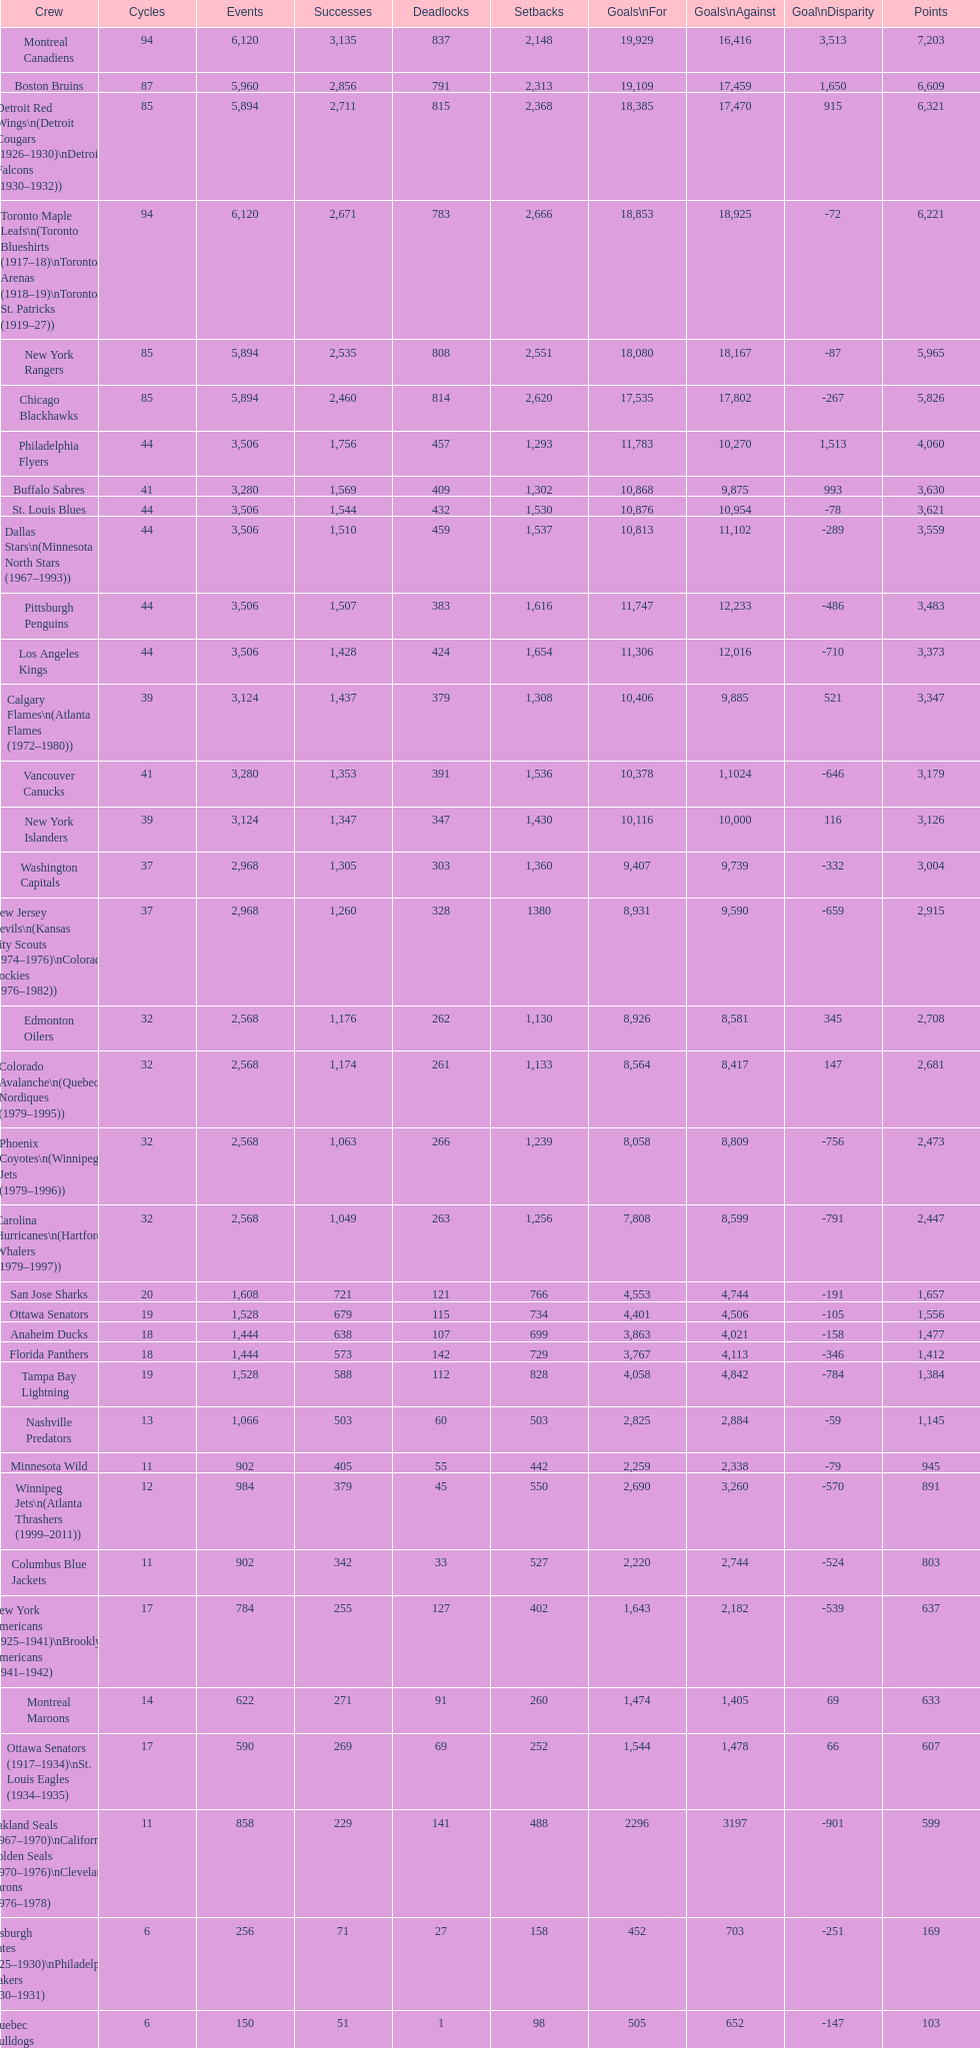Could you help me parse every detail presented in this table? {'header': ['Crew', 'Cycles', 'Events', 'Successes', 'Deadlocks', 'Setbacks', 'Goals\\nFor', 'Goals\\nAgainst', 'Goal\\nDisparity', 'Points'], 'rows': [['Montreal Canadiens', '94', '6,120', '3,135', '837', '2,148', '19,929', '16,416', '3,513', '7,203'], ['Boston Bruins', '87', '5,960', '2,856', '791', '2,313', '19,109', '17,459', '1,650', '6,609'], ['Detroit Red Wings\\n(Detroit Cougars (1926–1930)\\nDetroit Falcons (1930–1932))', '85', '5,894', '2,711', '815', '2,368', '18,385', '17,470', '915', '6,321'], ['Toronto Maple Leafs\\n(Toronto Blueshirts (1917–18)\\nToronto Arenas (1918–19)\\nToronto St. Patricks (1919–27))', '94', '6,120', '2,671', '783', '2,666', '18,853', '18,925', '-72', '6,221'], ['New York Rangers', '85', '5,894', '2,535', '808', '2,551', '18,080', '18,167', '-87', '5,965'], ['Chicago Blackhawks', '85', '5,894', '2,460', '814', '2,620', '17,535', '17,802', '-267', '5,826'], ['Philadelphia Flyers', '44', '3,506', '1,756', '457', '1,293', '11,783', '10,270', '1,513', '4,060'], ['Buffalo Sabres', '41', '3,280', '1,569', '409', '1,302', '10,868', '9,875', '993', '3,630'], ['St. Louis Blues', '44', '3,506', '1,544', '432', '1,530', '10,876', '10,954', '-78', '3,621'], ['Dallas Stars\\n(Minnesota North Stars (1967–1993))', '44', '3,506', '1,510', '459', '1,537', '10,813', '11,102', '-289', '3,559'], ['Pittsburgh Penguins', '44', '3,506', '1,507', '383', '1,616', '11,747', '12,233', '-486', '3,483'], ['Los Angeles Kings', '44', '3,506', '1,428', '424', '1,654', '11,306', '12,016', '-710', '3,373'], ['Calgary Flames\\n(Atlanta Flames (1972–1980))', '39', '3,124', '1,437', '379', '1,308', '10,406', '9,885', '521', '3,347'], ['Vancouver Canucks', '41', '3,280', '1,353', '391', '1,536', '10,378', '1,1024', '-646', '3,179'], ['New York Islanders', '39', '3,124', '1,347', '347', '1,430', '10,116', '10,000', '116', '3,126'], ['Washington Capitals', '37', '2,968', '1,305', '303', '1,360', '9,407', '9,739', '-332', '3,004'], ['New Jersey Devils\\n(Kansas City Scouts (1974–1976)\\nColorado Rockies (1976–1982))', '37', '2,968', '1,260', '328', '1380', '8,931', '9,590', '-659', '2,915'], ['Edmonton Oilers', '32', '2,568', '1,176', '262', '1,130', '8,926', '8,581', '345', '2,708'], ['Colorado Avalanche\\n(Quebec Nordiques (1979–1995))', '32', '2,568', '1,174', '261', '1,133', '8,564', '8,417', '147', '2,681'], ['Phoenix Coyotes\\n(Winnipeg Jets (1979–1996))', '32', '2,568', '1,063', '266', '1,239', '8,058', '8,809', '-756', '2,473'], ['Carolina Hurricanes\\n(Hartford Whalers (1979–1997))', '32', '2,568', '1,049', '263', '1,256', '7,808', '8,599', '-791', '2,447'], ['San Jose Sharks', '20', '1,608', '721', '121', '766', '4,553', '4,744', '-191', '1,657'], ['Ottawa Senators', '19', '1,528', '679', '115', '734', '4,401', '4,506', '-105', '1,556'], ['Anaheim Ducks', '18', '1,444', '638', '107', '699', '3,863', '4,021', '-158', '1,477'], ['Florida Panthers', '18', '1,444', '573', '142', '729', '3,767', '4,113', '-346', '1,412'], ['Tampa Bay Lightning', '19', '1,528', '588', '112', '828', '4,058', '4,842', '-784', '1,384'], ['Nashville Predators', '13', '1,066', '503', '60', '503', '2,825', '2,884', '-59', '1,145'], ['Minnesota Wild', '11', '902', '405', '55', '442', '2,259', '2,338', '-79', '945'], ['Winnipeg Jets\\n(Atlanta Thrashers (1999–2011))', '12', '984', '379', '45', '550', '2,690', '3,260', '-570', '891'], ['Columbus Blue Jackets', '11', '902', '342', '33', '527', '2,220', '2,744', '-524', '803'], ['New York Americans (1925–1941)\\nBrooklyn Americans (1941–1942)', '17', '784', '255', '127', '402', '1,643', '2,182', '-539', '637'], ['Montreal Maroons', '14', '622', '271', '91', '260', '1,474', '1,405', '69', '633'], ['Ottawa Senators (1917–1934)\\nSt. Louis Eagles (1934–1935)', '17', '590', '269', '69', '252', '1,544', '1,478', '66', '607'], ['Oakland Seals (1967–1970)\\nCalifornia Golden Seals (1970–1976)\\nCleveland Barons (1976–1978)', '11', '858', '229', '141', '488', '2296', '3197', '-901', '599'], ['Pittsburgh Pirates (1925–1930)\\nPhiladelphia Quakers (1930–1931)', '6', '256', '71', '27', '158', '452', '703', '-251', '169'], ['Quebec Bulldogs (1919–1920)\\nHamilton Tigers (1920–1925)', '6', '150', '51', '1', '98', '505', '652', '-147', '103'], ['Montreal Wanderers', '1', '6', '1', '0', '5', '17', '35', '-18', '2']]} What is the number of games that the vancouver canucks have won up to this point? 1,353. 